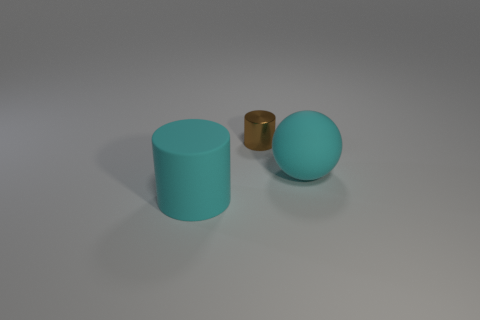Add 2 tiny brown cylinders. How many objects exist? 5 Subtract all balls. How many objects are left? 2 Add 3 tiny brown blocks. How many tiny brown blocks exist? 3 Subtract 0 red balls. How many objects are left? 3 Subtract all cyan matte objects. Subtract all large brown matte things. How many objects are left? 1 Add 1 big cylinders. How many big cylinders are left? 2 